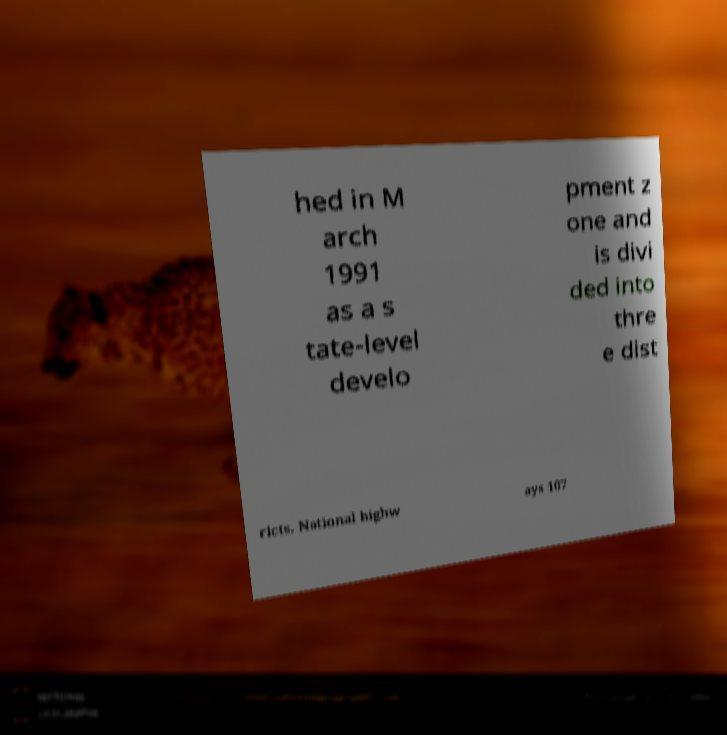What messages or text are displayed in this image? I need them in a readable, typed format. hed in M arch 1991 as a s tate-level develo pment z one and is divi ded into thre e dist ricts. National highw ays 107 